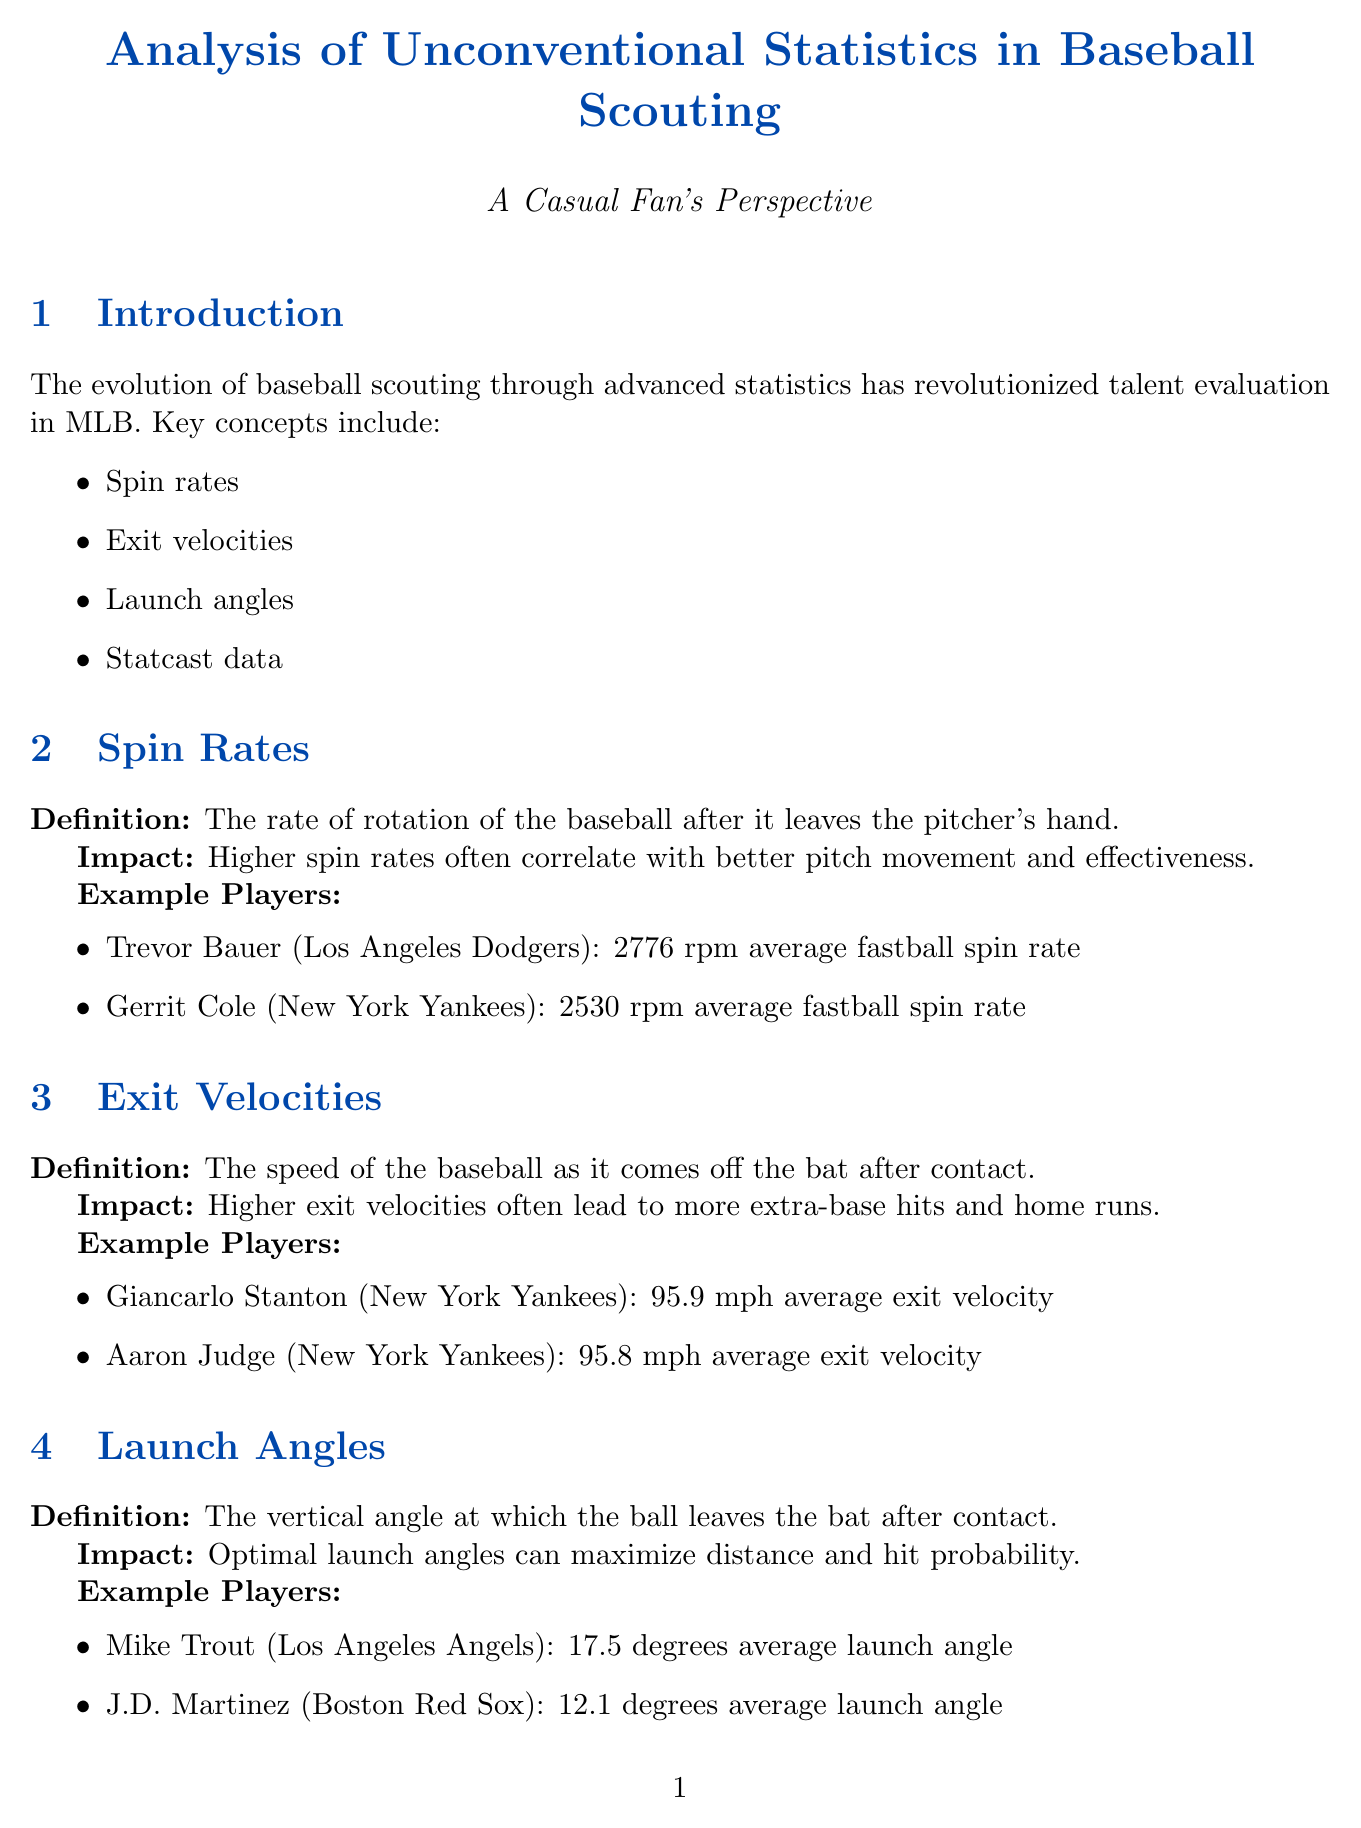What is the average fastball spin rate of Trevor Bauer? Trevor Bauer's average fastball spin rate is specified in the document under the spin rates section.
Answer: 2776 rpm What is the average exit velocity of Giancarlo Stanton? Giancarlo Stanton's average exit velocity is detailed in the exit velocities section of the report.
Answer: 95.9 mph What was Justin Turner's launch angle before adjustment in 2013? The document lists Justin Turner's launch angle before adjustment in the case study section.
Answer: 10.2 degrees Which team does Gerrit Cole play for? Gerrit Cole's team is mentioned in the spin rates section under example players.
Answer: New York Yankees How did Charlie Morton's curveball spin rate change from 2015 to 2020? The document provides details on the change in Charlie Morton's curveball spin rate in the case studies section.
Answer: 2306 rpm to 2836 rpm What key concept is associated with maximizing distance and hit probability? The document connects this impact to launch angles specifically in the launch angles section.
Answer: Launch angles What are the challenges mentioned in balancing traditional and data-driven scouting methods? The document discusses challenges under the challenges section, focusing on balancing methods.
Answer: Balancing traditional scouting methods with data-driven approaches What is one future trend noted in the report regarding player evaluation? The document lists various future trends that are expected in scouting processes in the future trends section.
Answer: Integration of artificial intelligence in scouting processes 